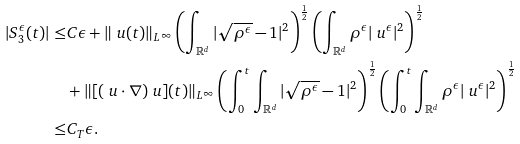<formula> <loc_0><loc_0><loc_500><loc_500>| S ^ { \epsilon } _ { 3 } ( t ) | \leq & C \epsilon + \| \ u ( t ) \| _ { L ^ { \infty } } \left ( \int _ { \mathbb { R } ^ { d } } | \sqrt { \rho ^ { \epsilon } } - 1 | ^ { 2 } \right ) ^ { \frac { 1 } { 2 } } \left ( \int _ { \mathbb { R } ^ { d } } \rho ^ { \epsilon } | \ u ^ { \epsilon } | ^ { 2 } \right ) ^ { \frac { 1 } { 2 } } \\ & + \| [ ( \ u \cdot \nabla ) \ u ] ( t ) \| _ { L ^ { \infty } } \left ( \int ^ { t } _ { 0 } \int _ { \mathbb { R } ^ { d } } | \sqrt { \rho ^ { \epsilon } } - 1 | ^ { 2 } \right ) ^ { \frac { 1 } { 2 } } \left ( \int ^ { t } _ { 0 } \int _ { \mathbb { R } ^ { d } } \rho ^ { \epsilon } | \ u ^ { \epsilon } | ^ { 2 } \right ) ^ { \frac { 1 } { 2 } } \\ \leq & C _ { T } \epsilon .</formula> 